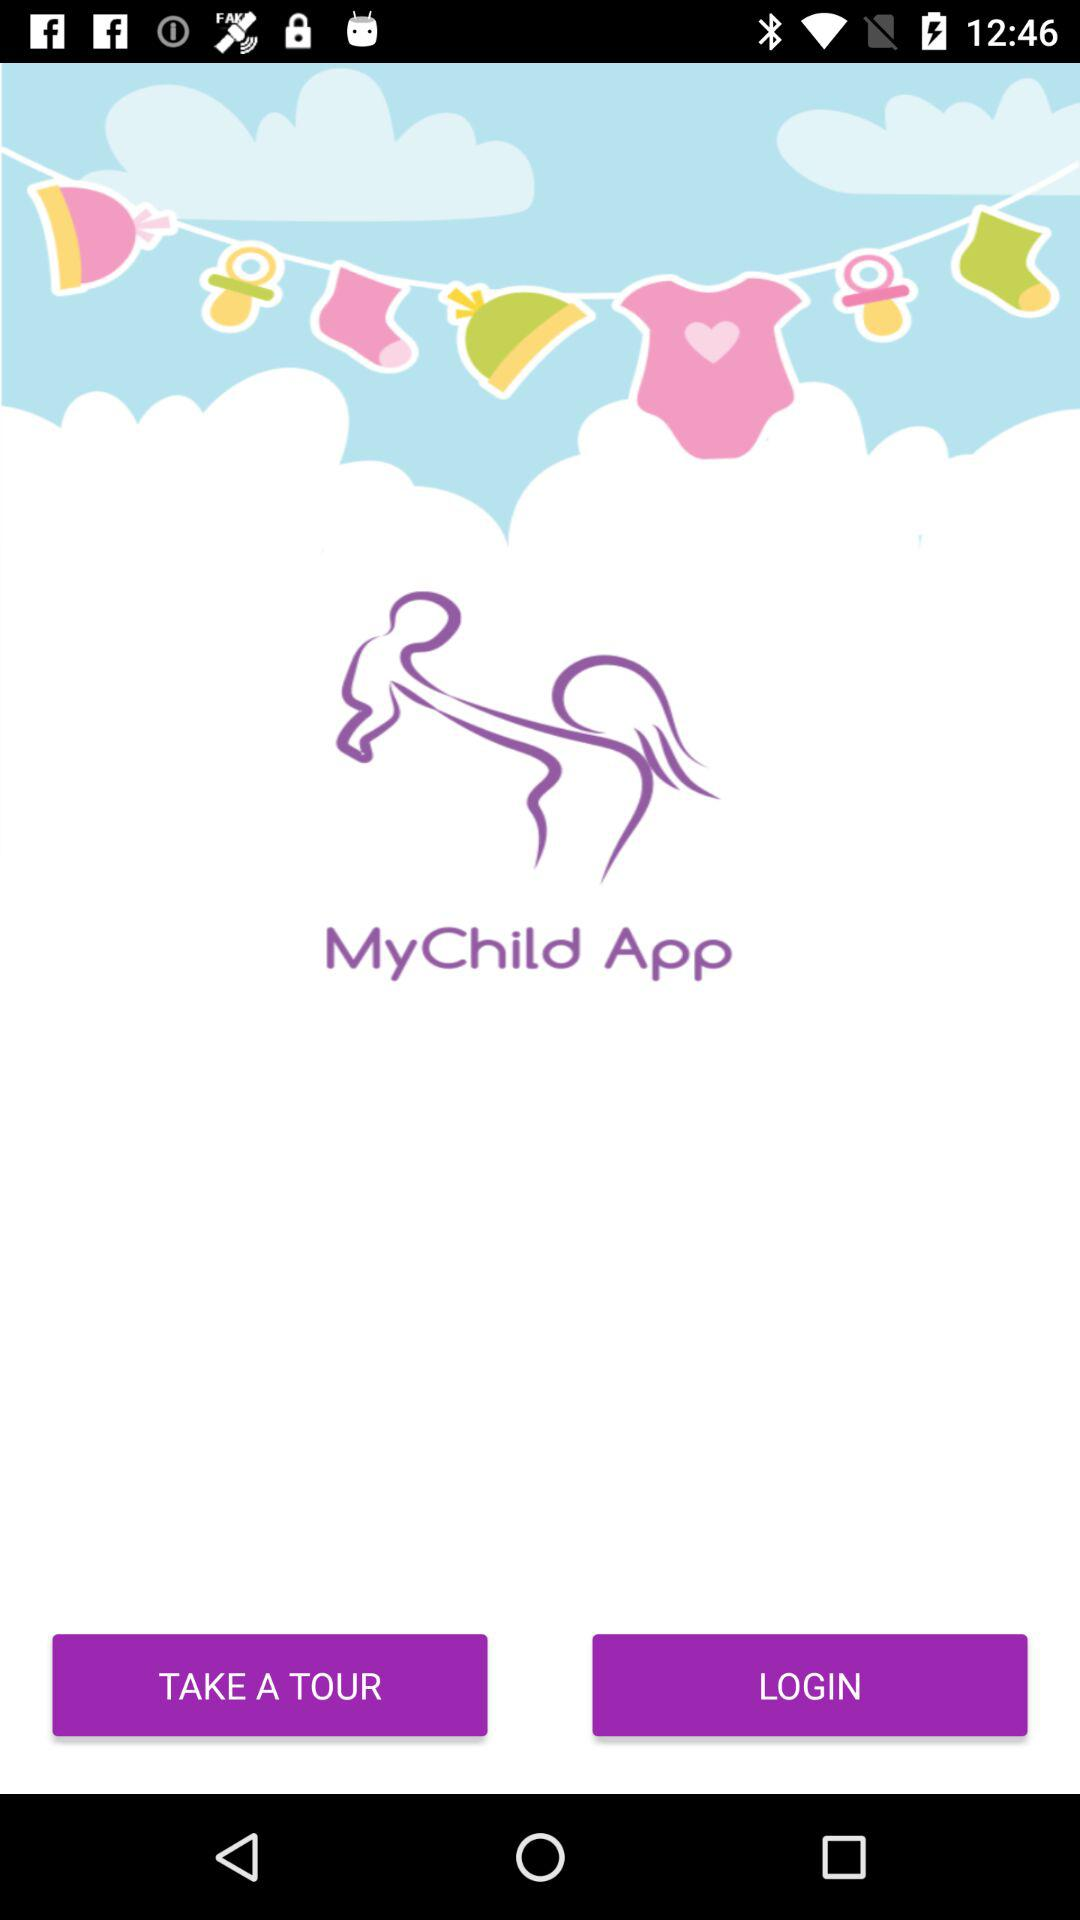What is the application name? The application name is "MyChild App". 